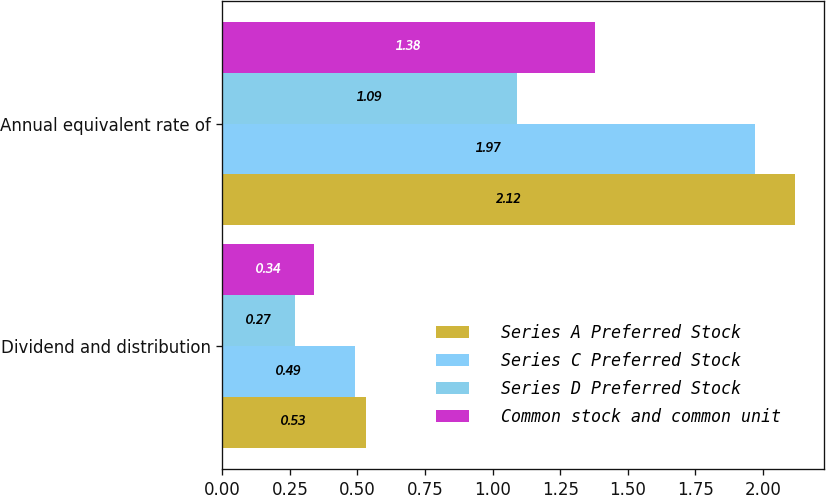Convert chart to OTSL. <chart><loc_0><loc_0><loc_500><loc_500><stacked_bar_chart><ecel><fcel>Dividend and distribution<fcel>Annual equivalent rate of<nl><fcel>Series A Preferred Stock<fcel>0.53<fcel>2.12<nl><fcel>Series C Preferred Stock<fcel>0.49<fcel>1.97<nl><fcel>Series D Preferred Stock<fcel>0.27<fcel>1.09<nl><fcel>Common stock and common unit<fcel>0.34<fcel>1.38<nl></chart> 